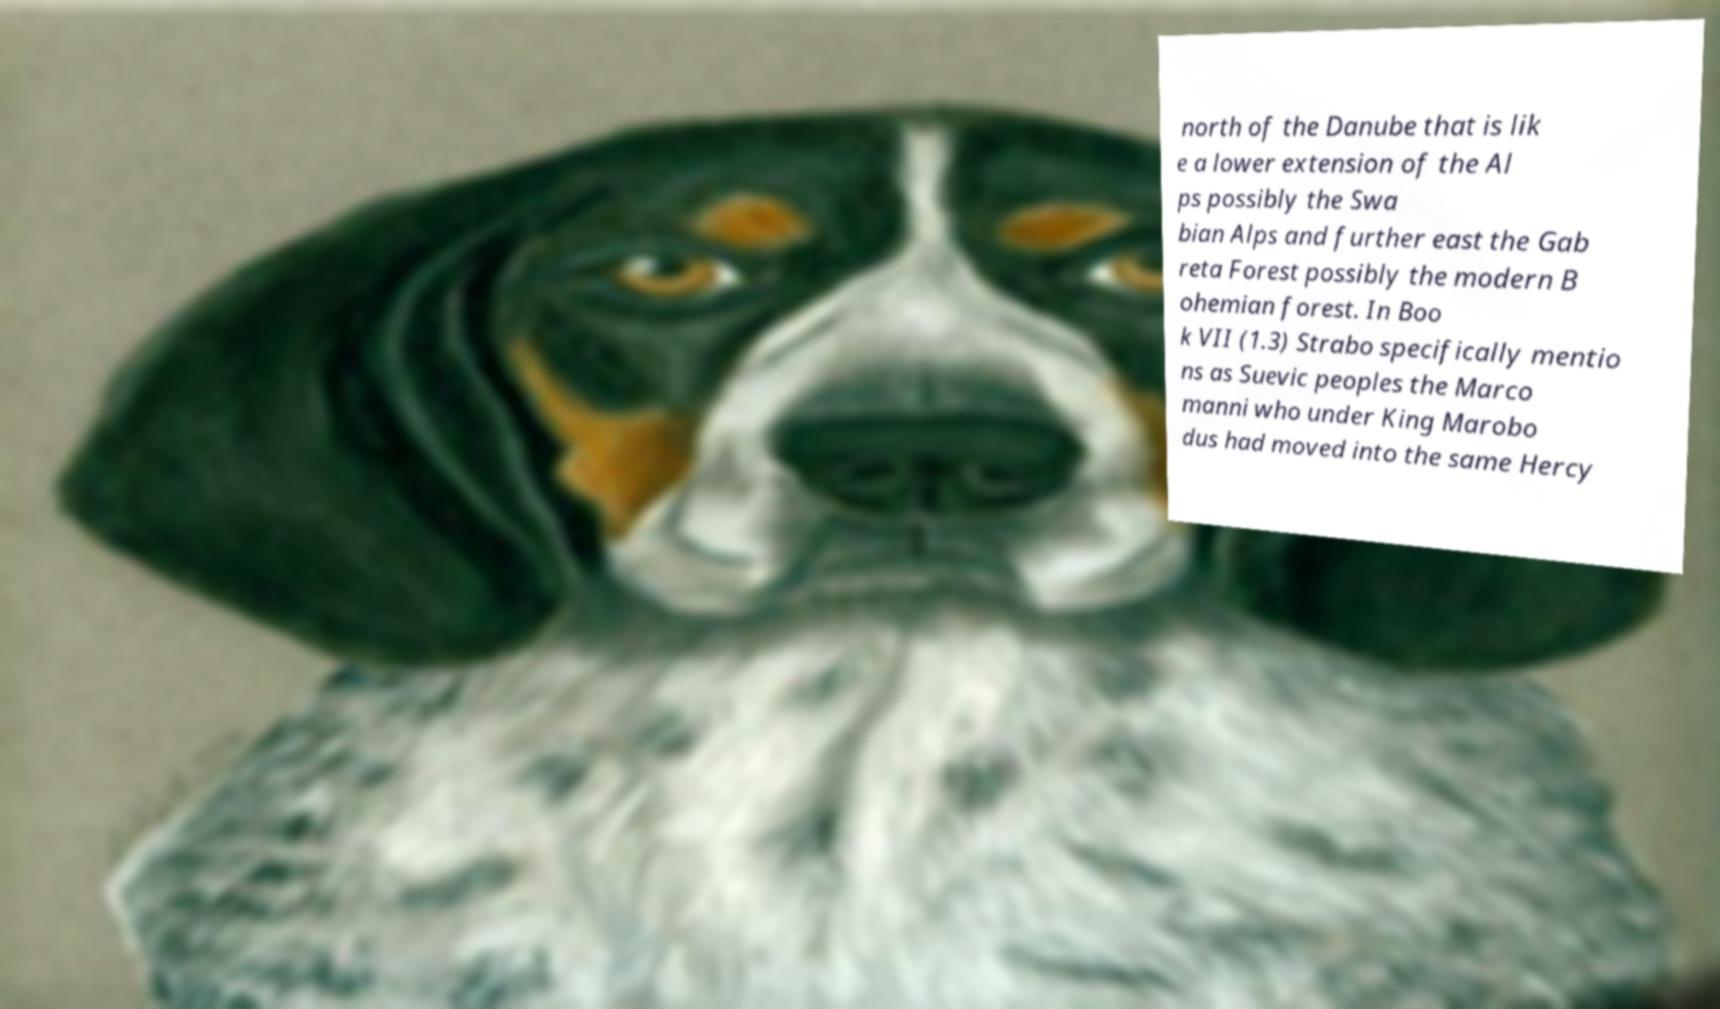What messages or text are displayed in this image? I need them in a readable, typed format. north of the Danube that is lik e a lower extension of the Al ps possibly the Swa bian Alps and further east the Gab reta Forest possibly the modern B ohemian forest. In Boo k VII (1.3) Strabo specifically mentio ns as Suevic peoples the Marco manni who under King Marobo dus had moved into the same Hercy 